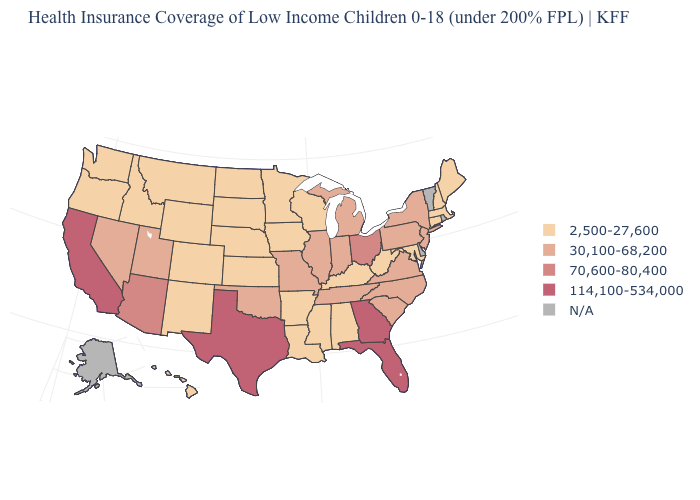Is the legend a continuous bar?
Short answer required. No. What is the value of Washington?
Answer briefly. 2,500-27,600. What is the value of Utah?
Be succinct. 30,100-68,200. Name the states that have a value in the range N/A?
Give a very brief answer. Alaska, Delaware, Rhode Island, Vermont. Does Indiana have the lowest value in the MidWest?
Give a very brief answer. No. What is the value of Tennessee?
Give a very brief answer. 30,100-68,200. Name the states that have a value in the range 114,100-534,000?
Write a very short answer. California, Florida, Georgia, Texas. Is the legend a continuous bar?
Quick response, please. No. Does Massachusetts have the lowest value in the Northeast?
Write a very short answer. Yes. Among the states that border Delaware , which have the highest value?
Quick response, please. New Jersey, Pennsylvania. What is the highest value in the USA?
Short answer required. 114,100-534,000. Name the states that have a value in the range 70,600-80,400?
Write a very short answer. Arizona, Ohio. What is the value of Alabama?
Write a very short answer. 2,500-27,600. 